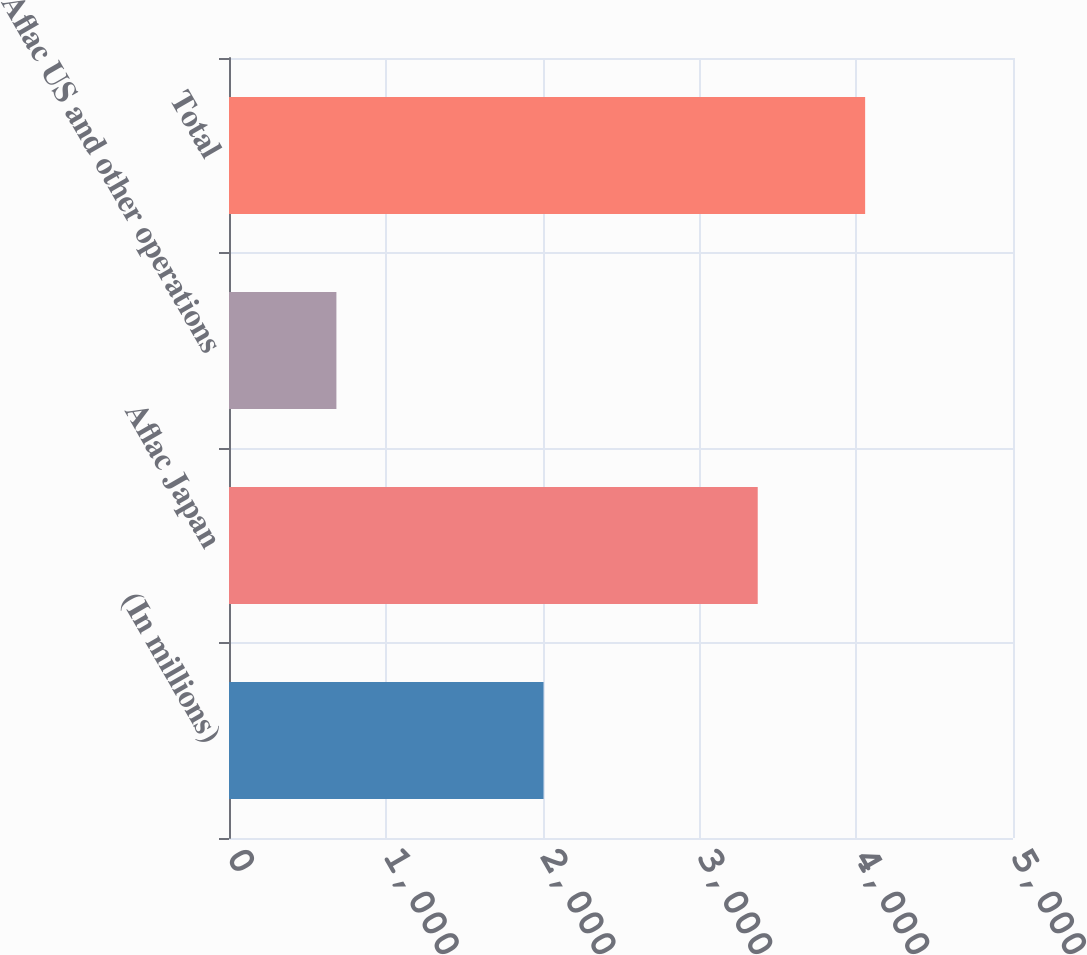<chart> <loc_0><loc_0><loc_500><loc_500><bar_chart><fcel>(In millions)<fcel>Aflac Japan<fcel>Aflac US and other operations<fcel>Total<nl><fcel>2006<fcel>3372<fcel>685<fcel>4057<nl></chart> 